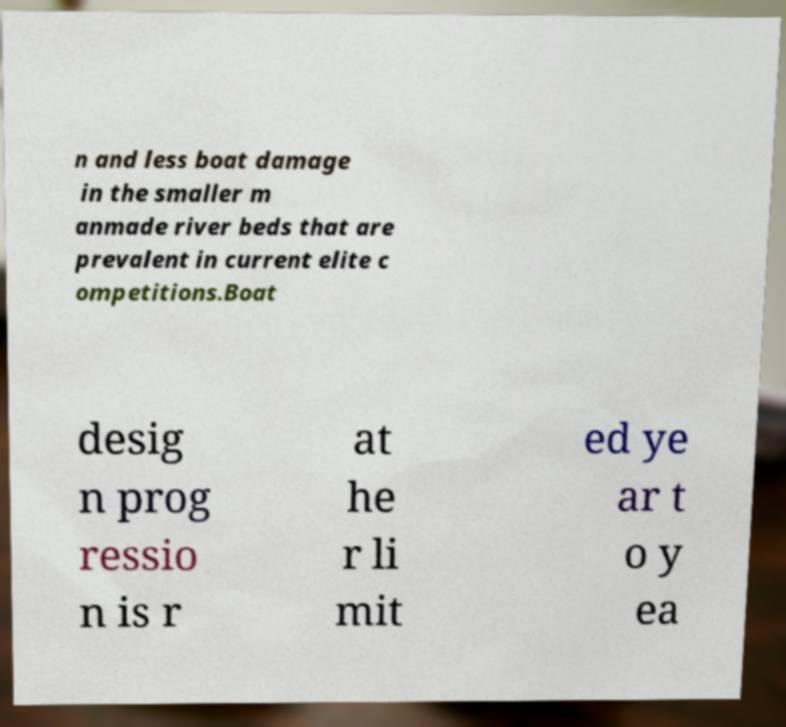Could you extract and type out the text from this image? n and less boat damage in the smaller m anmade river beds that are prevalent in current elite c ompetitions.Boat desig n prog ressio n is r at he r li mit ed ye ar t o y ea 